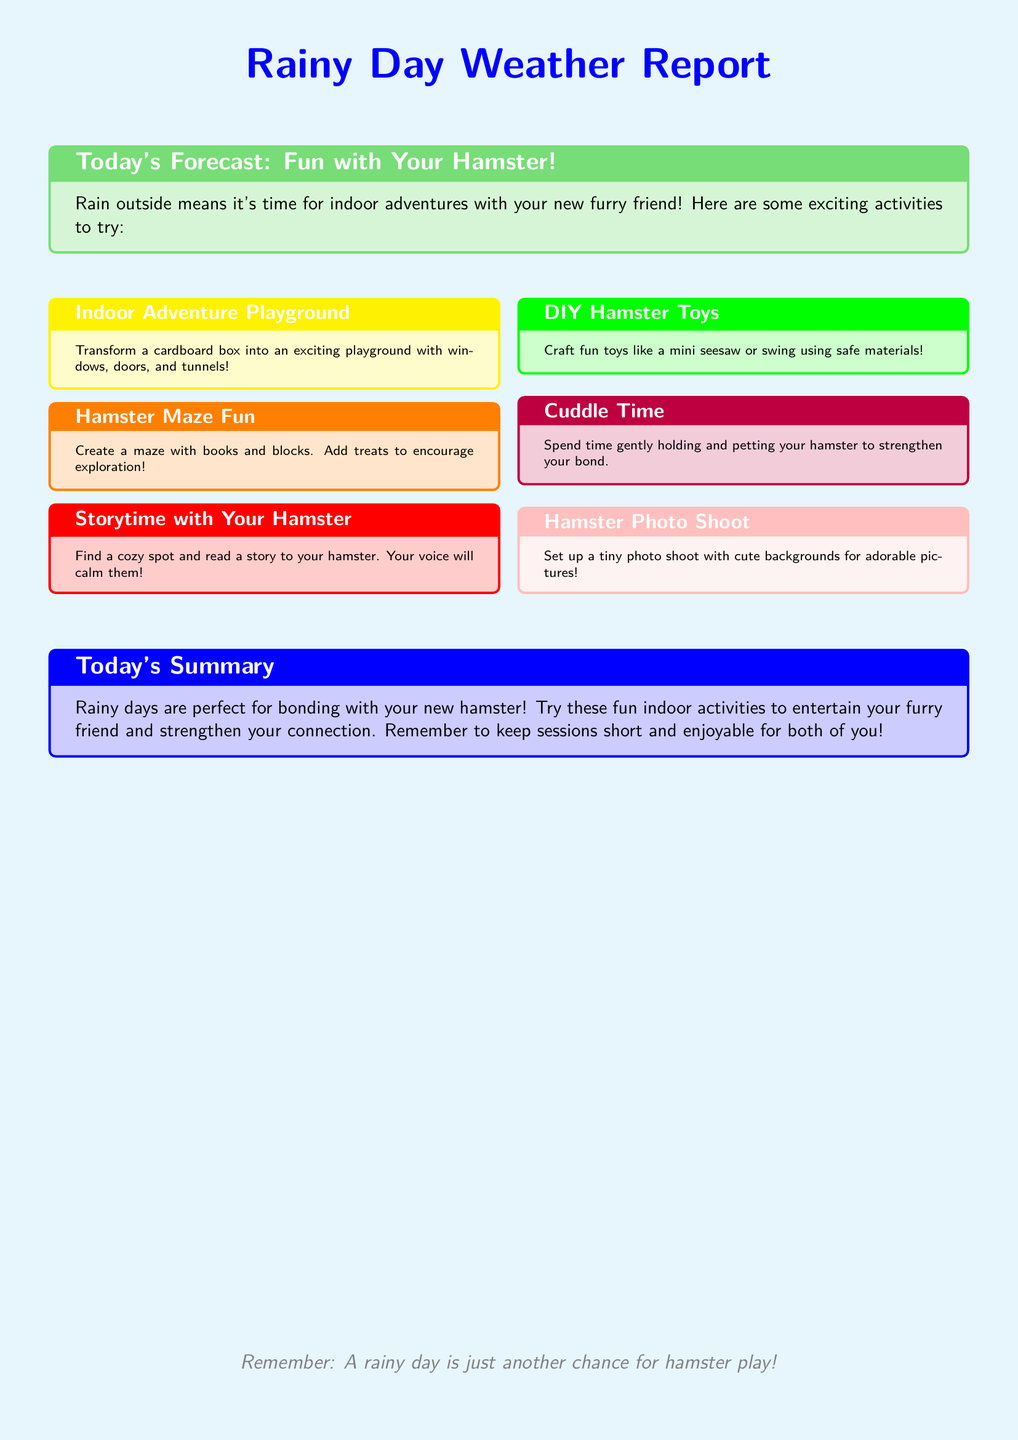What is the title of the weather report? The title of the weather report is prominently displayed at the top of the document, which indicates the theme and content.
Answer: Rainy Day Weather Report What color is the background of the document? The background color of the document is described by the coding of the page color which is a light blue shade.
Answer: Baby blue What activity involves using a cardboard box? The document outlines a specific indoor activity involving a cardboard box to create a fun play area for the hamster.
Answer: Indoor Adventure Playground How should the maze be created? The maze is suggested to be made using various materials to encourage exploration, as specified in the documented activity.
Answer: Books and blocks What is the purpose of storytime with the hamster? The activity is intended to provide comfort and bonding time for both the hamster and its owner.
Answer: Calm them What materials are suggested for crafting hamster toys? The document highlights that the toys should be made from safe materials for the hamster's well-being.
Answer: Safe materials How many activities are listed in the document? By counting the activities listed in the document, a specific number can be determined.
Answer: Six What does the summary suggest about rainy days? The summary reflects on the opportunities that rainy days provide for interacting with pets.
Answer: Bonding with your new hamster What is mentioned as an essential aspect of the interaction sessions? The summary emphasizes an important factor to consider during bonding time with the hamster.
Answer: Keep sessions short and enjoyable 